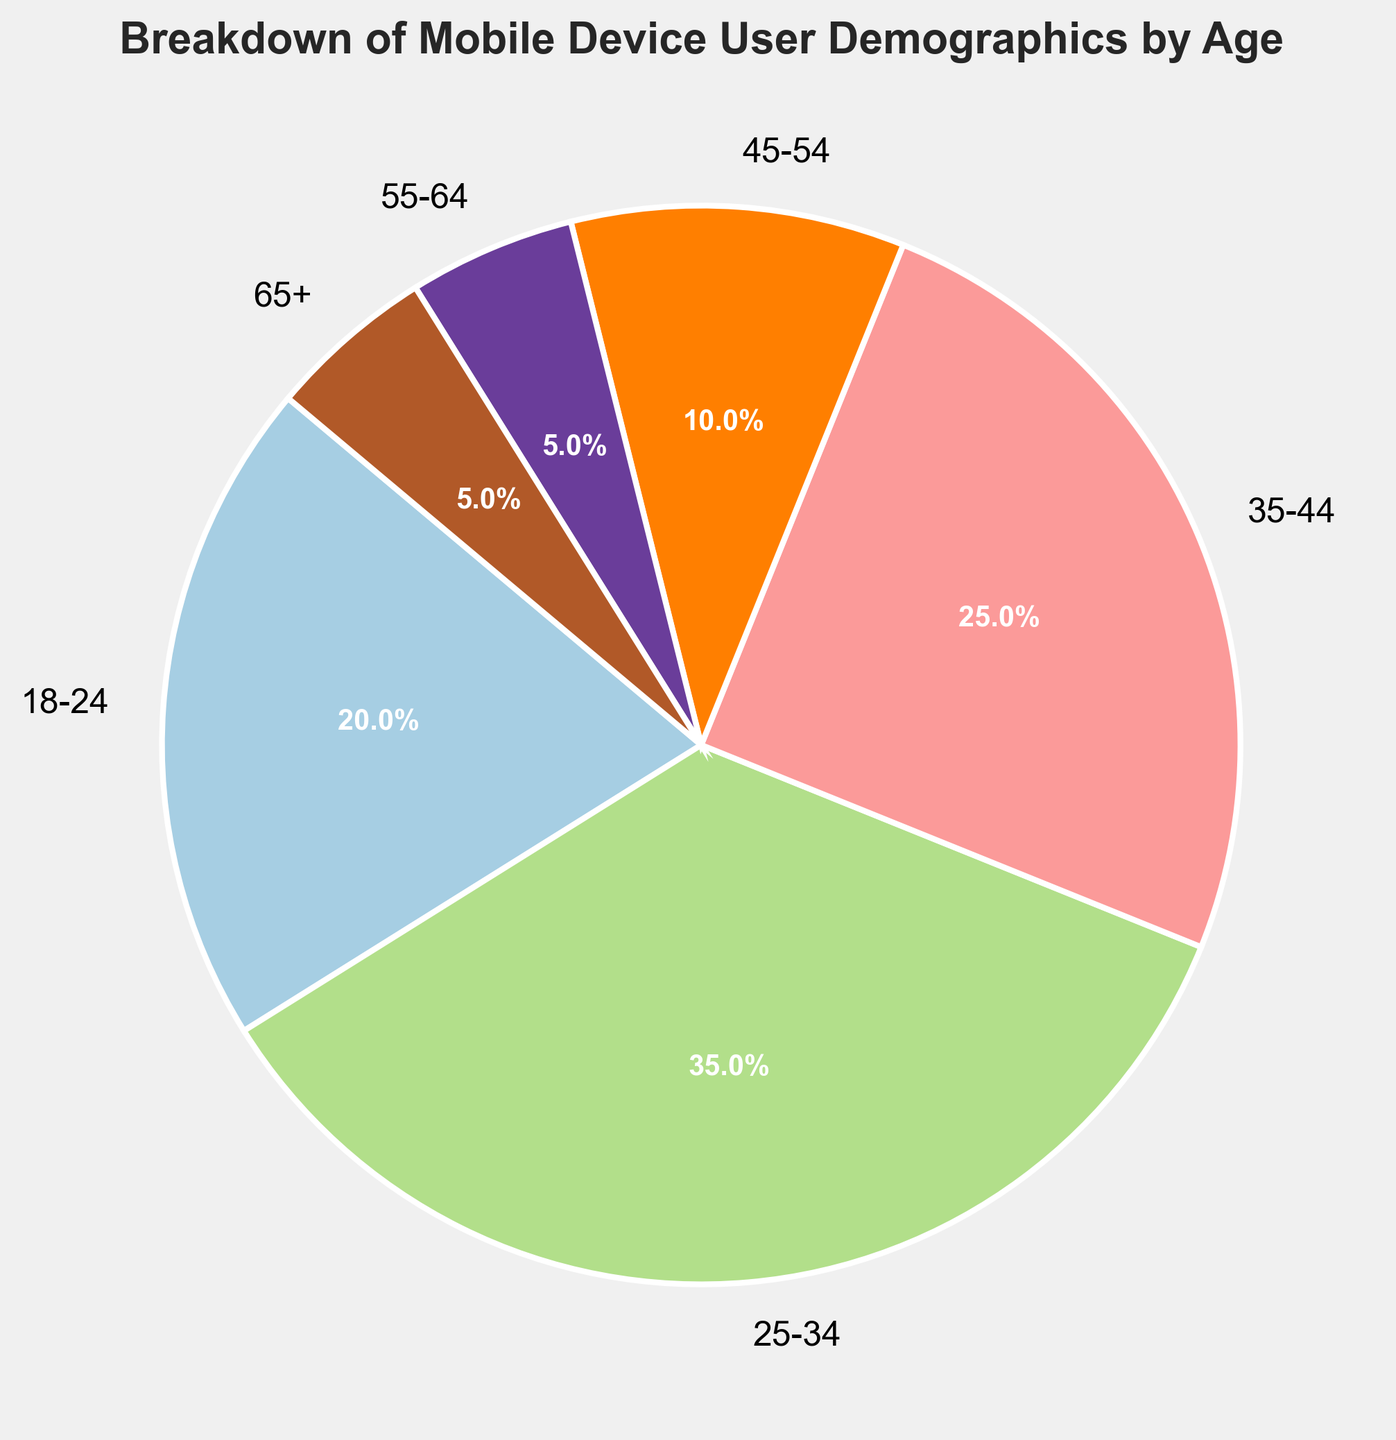What's the largest age group in the mobile device user demographics? The pie chart shows different age groups and their corresponding percentages. The biggest slice on the pie chart corresponds to age group 25-34, which is 35%.
Answer: 25-34 Which age groups have the lowest percentage of mobile device users? The chart reveals the age groups and respective percentages. The smallest slices represent age groups 55-64 and 65+, both at 5%.
Answer: 55-64 and 65+ How much higher is the percentage of users aged 25-34 compared to those aged 18-24? According to the pie chart, 25-34 is 35% and 18-24 is 20%. The difference is 35% - 20% = 15%.
Answer: 15% What is the combined percentage of users aged 35-44 and 45-54? Adding the percentages for 35-44 and 45-54 gives 25% + 10% = 35%.
Answer: 35% Which age group represents double the percentage of the 18-24 age group? The 18-24 group is at 20%. Doubling that, 20% × 2 = 40%. The closest age group in the chart to this figure is none; the highest individual group is 35%.
Answer: None Among the mobile device user demographics, which two age groups have equal percentages? Reviewing the pie chart, age groups 55-64 and 65+ each represent 5% of users, making them equal.
Answer: 55-64 and 65+ What is the difference in percentage between the oldest and youngest age groups in the mobile device user demographics? The oldest age group (65+) has 5%, and the youngest age group (18-24) has 20%. The difference is 20% - 5% = 15%.
Answer: 15% How does the percentage of users in the 35-44 age group compare to those in the 45-54 age group? From the pie chart, users aged 35-44 are at 25%, and those aged 45-54 are at 10%. 25% is more than double 10%.
Answer: 35-44 is more than double 45-54 Which age group forms a quarter of the total mobile device user demographics? The pie chart shows age group 35-44 forms exactly 25% of the total demographics.
Answer: 35-44 